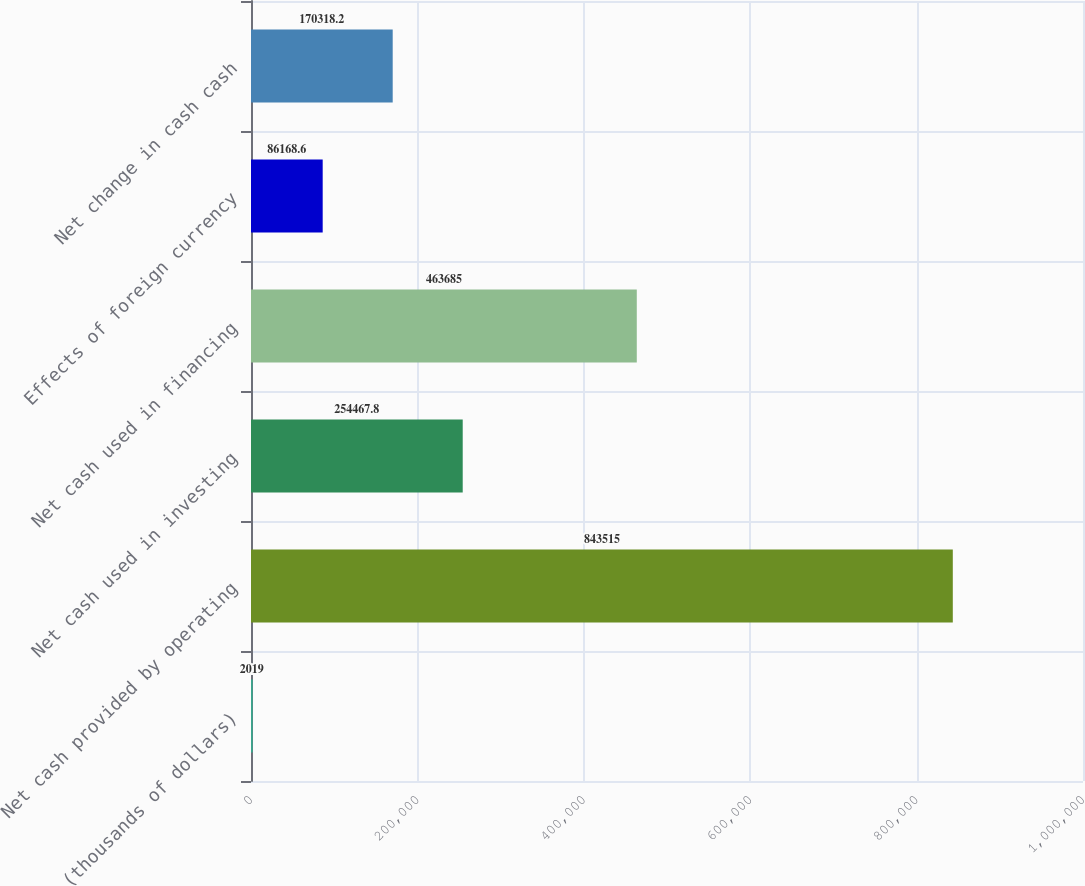Convert chart to OTSL. <chart><loc_0><loc_0><loc_500><loc_500><bar_chart><fcel>(thousands of dollars)<fcel>Net cash provided by operating<fcel>Net cash used in investing<fcel>Net cash used in financing<fcel>Effects of foreign currency<fcel>Net change in cash cash<nl><fcel>2019<fcel>843515<fcel>254468<fcel>463685<fcel>86168.6<fcel>170318<nl></chart> 